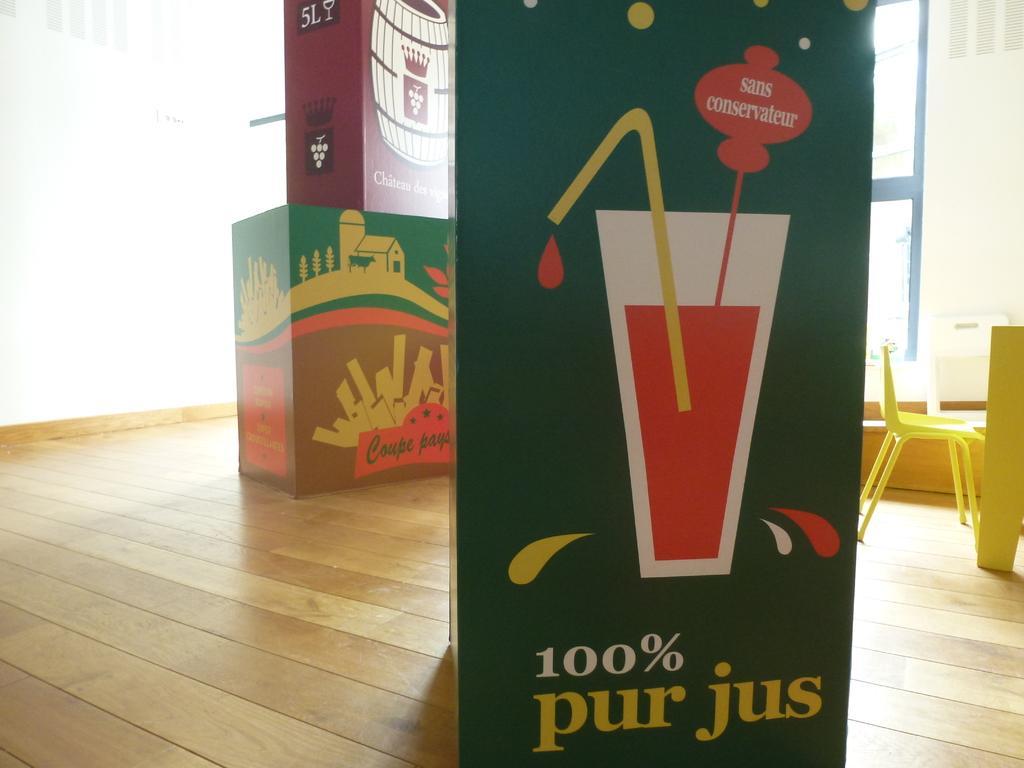Can you describe this image briefly? This is an inside view. Here I can see few card boxes are placed on the floor. On the left side there is wall. On the right side a table and a chair are placed on the floor. 